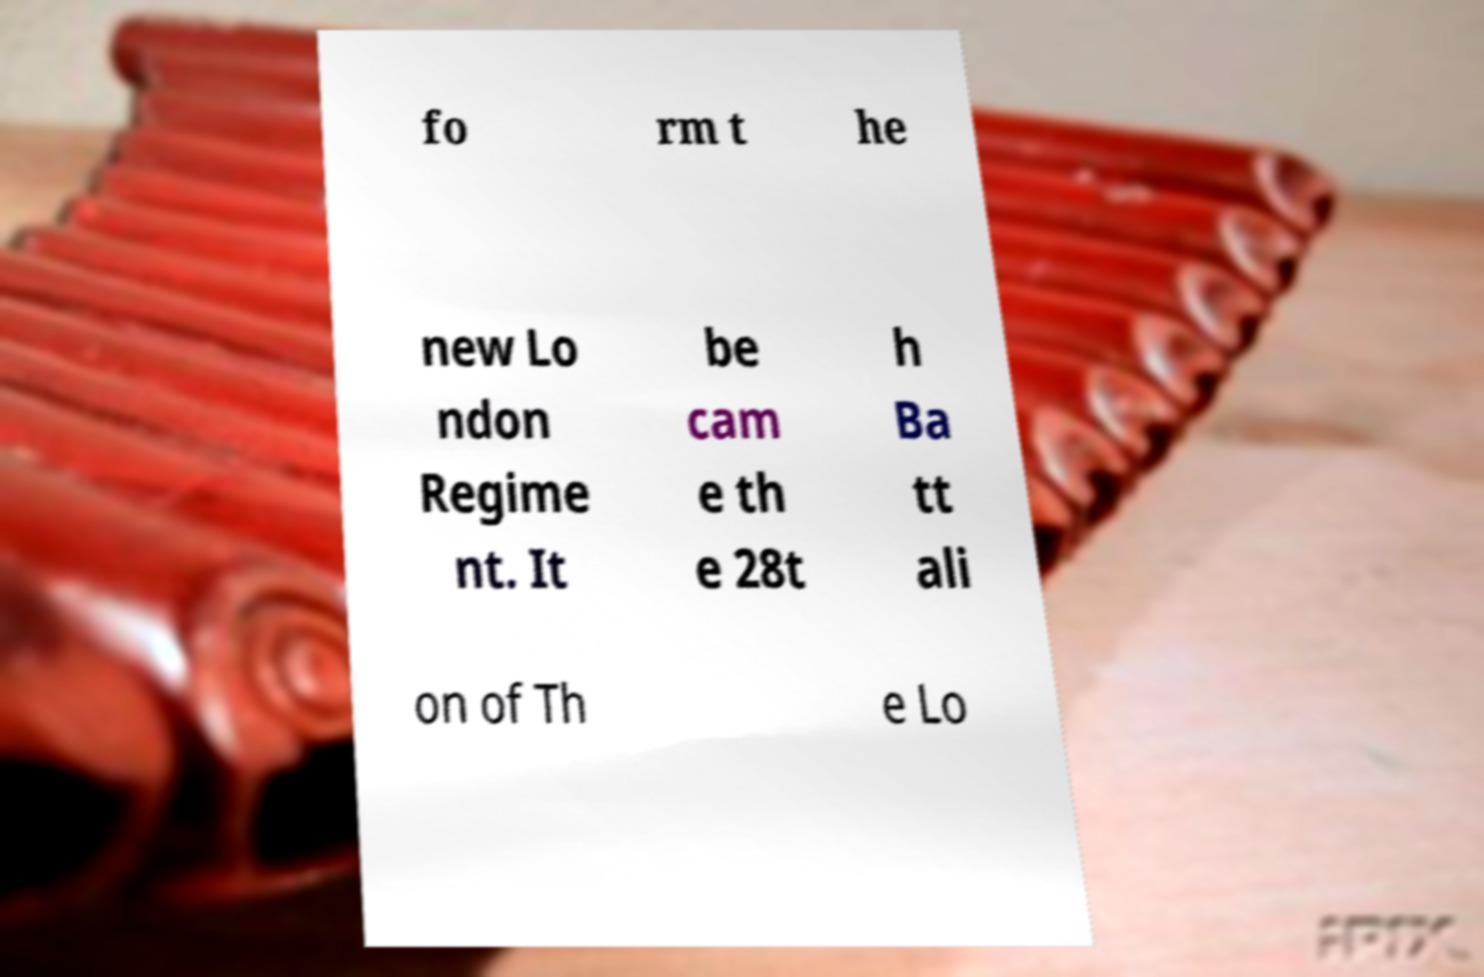Can you accurately transcribe the text from the provided image for me? fo rm t he new Lo ndon Regime nt. It be cam e th e 28t h Ba tt ali on of Th e Lo 